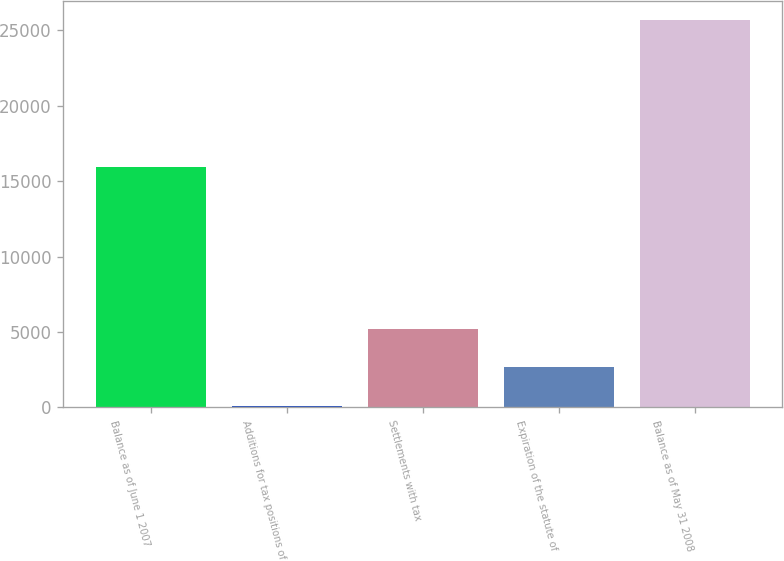<chart> <loc_0><loc_0><loc_500><loc_500><bar_chart><fcel>Balance as of June 1 2007<fcel>Additions for tax positions of<fcel>Settlements with tax<fcel>Expiration of the statute of<fcel>Balance as of May 31 2008<nl><fcel>15911<fcel>102<fcel>5216.2<fcel>2659.1<fcel>25673<nl></chart> 